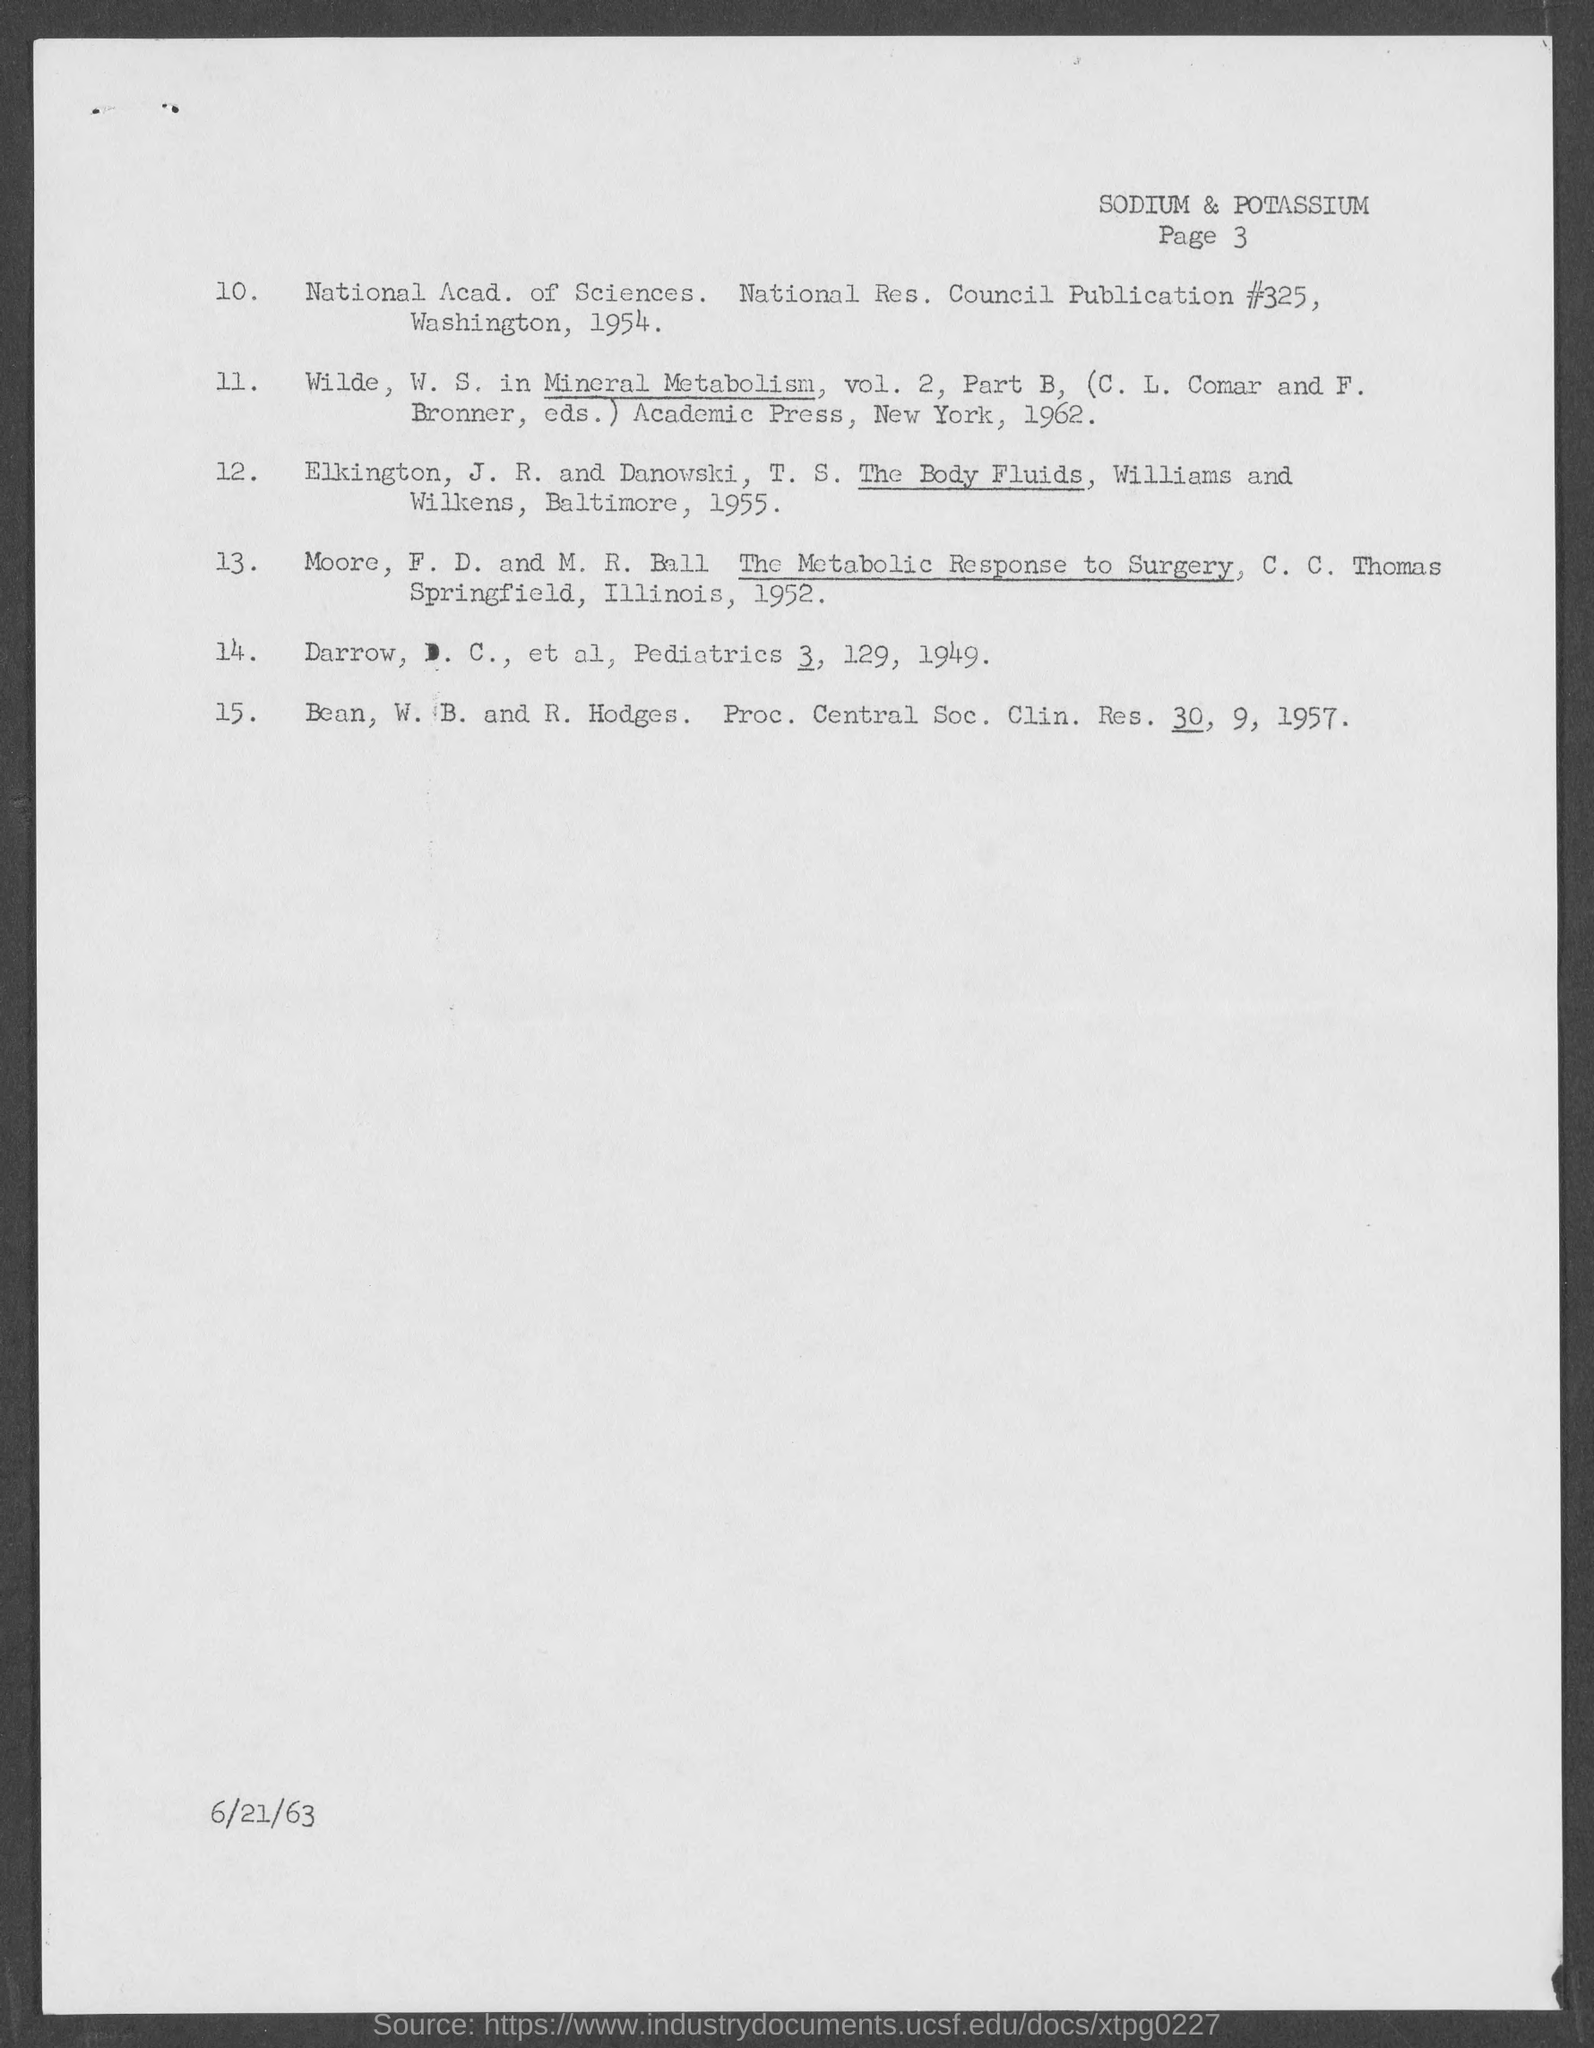What is the page number at top of the page ?
Your response must be concise. Page 3. What is the date at bottom of the page ?
Your answer should be compact. 6/21/63. 